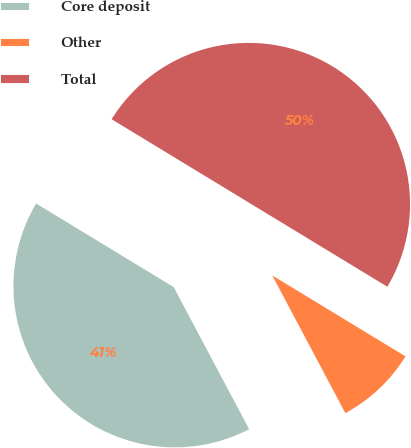Convert chart. <chart><loc_0><loc_0><loc_500><loc_500><pie_chart><fcel>Core deposit<fcel>Other<fcel>Total<nl><fcel>41.46%<fcel>8.54%<fcel>50.0%<nl></chart> 